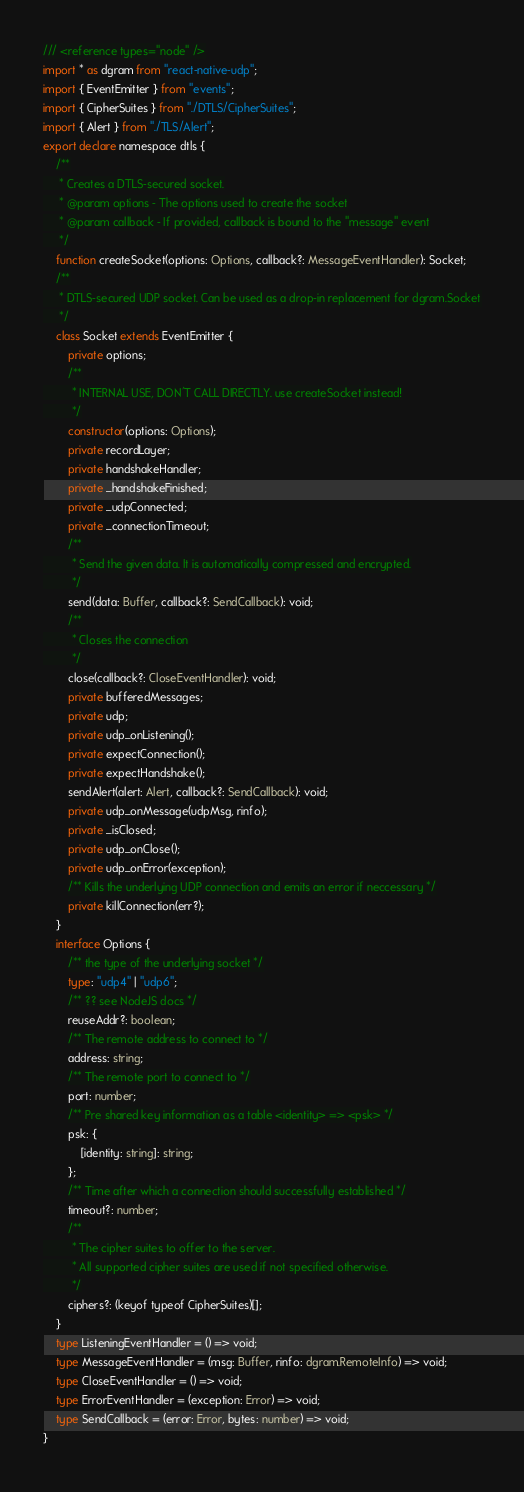<code> <loc_0><loc_0><loc_500><loc_500><_TypeScript_>/// <reference types="node" />
import * as dgram from "react-native-udp";
import { EventEmitter } from "events";
import { CipherSuites } from "./DTLS/CipherSuites";
import { Alert } from "./TLS/Alert";
export declare namespace dtls {
    /**
     * Creates a DTLS-secured socket.
     * @param options - The options used to create the socket
     * @param callback - If provided, callback is bound to the "message" event
     */
    function createSocket(options: Options, callback?: MessageEventHandler): Socket;
    /**
     * DTLS-secured UDP socket. Can be used as a drop-in replacement for dgram.Socket
     */
    class Socket extends EventEmitter {
        private options;
        /**
         * INTERNAL USE, DON'T CALL DIRECTLY. use createSocket instead!
         */
        constructor(options: Options);
        private recordLayer;
        private handshakeHandler;
        private _handshakeFinished;
        private _udpConnected;
        private _connectionTimeout;
        /**
         * Send the given data. It is automatically compressed and encrypted.
         */
        send(data: Buffer, callback?: SendCallback): void;
        /**
         * Closes the connection
         */
        close(callback?: CloseEventHandler): void;
        private bufferedMessages;
        private udp;
        private udp_onListening();
        private expectConnection();
        private expectHandshake();
        sendAlert(alert: Alert, callback?: SendCallback): void;
        private udp_onMessage(udpMsg, rinfo);
        private _isClosed;
        private udp_onClose();
        private udp_onError(exception);
        /** Kills the underlying UDP connection and emits an error if neccessary */
        private killConnection(err?);
    }
    interface Options {
        /** the type of the underlying socket */
        type: "udp4" | "udp6";
        /** ?? see NodeJS docs */
        reuseAddr?: boolean;
        /** The remote address to connect to */
        address: string;
        /** The remote port to connect to */
        port: number;
        /** Pre shared key information as a table <identity> => <psk> */
        psk: {
            [identity: string]: string;
        };
        /** Time after which a connection should successfully established */
        timeout?: number;
        /**
         * The cipher suites to offer to the server.
         * All supported cipher suites are used if not specified otherwise.
         */
        ciphers?: (keyof typeof CipherSuites)[];
    }
    type ListeningEventHandler = () => void;
    type MessageEventHandler = (msg: Buffer, rinfo: dgram.RemoteInfo) => void;
    type CloseEventHandler = () => void;
    type ErrorEventHandler = (exception: Error) => void;
    type SendCallback = (error: Error, bytes: number) => void;
}
</code> 